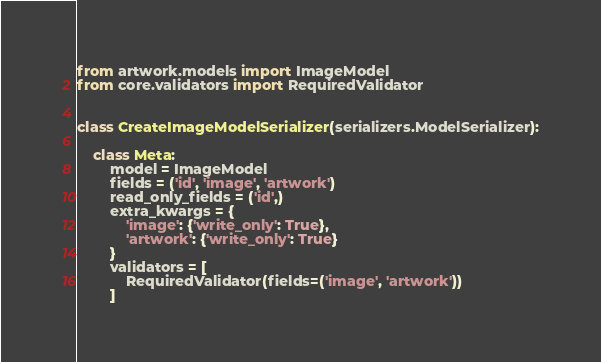Convert code to text. <code><loc_0><loc_0><loc_500><loc_500><_Python_>
from artwork.models import ImageModel
from core.validators import RequiredValidator


class CreateImageModelSerializer(serializers.ModelSerializer):

	class Meta:
		model = ImageModel
		fields = ('id', 'image', 'artwork')
		read_only_fields = ('id',)
		extra_kwargs = {
			'image': {'write_only': True},
			'artwork': {'write_only': True}
		}
		validators = [
			RequiredValidator(fields=('image', 'artwork'))
		]
</code> 